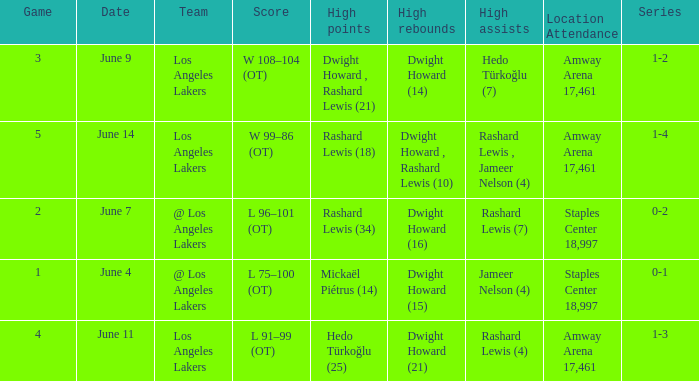What is High Assists, when High Rebounds is "Dwight Howard , Rashard Lewis (10)"? Rashard Lewis , Jameer Nelson (4). 